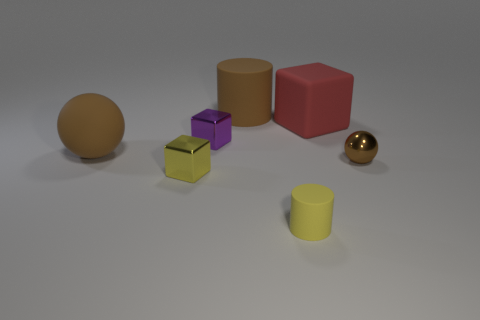What time of day does the lighting in this image suggest? The lighting in the image is soft and diffused, with no strong shadows, which might suggest an overcast day or a setting with artificial lighting designed to minimize shadows, such as a studio with softbox lighting. It's difficult to pinpoint the exact time of day based solely on the lighting here. 